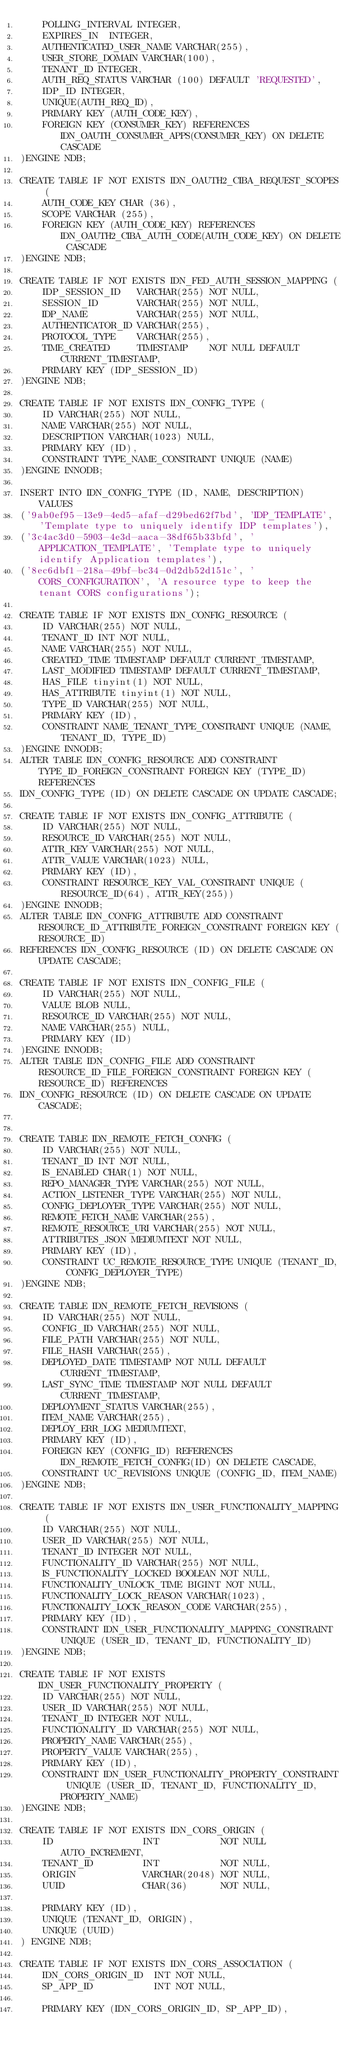Convert code to text. <code><loc_0><loc_0><loc_500><loc_500><_SQL_>    POLLING_INTERVAL INTEGER,
    EXPIRES_IN  INTEGER,
    AUTHENTICATED_USER_NAME VARCHAR(255),
    USER_STORE_DOMAIN VARCHAR(100),
    TENANT_ID INTEGER,
    AUTH_REQ_STATUS VARCHAR (100) DEFAULT 'REQUESTED',
    IDP_ID INTEGER,
    UNIQUE(AUTH_REQ_ID),
    PRIMARY KEY (AUTH_CODE_KEY),
    FOREIGN KEY (CONSUMER_KEY) REFERENCES IDN_OAUTH_CONSUMER_APPS(CONSUMER_KEY) ON DELETE CASCADE
)ENGINE NDB;

CREATE TABLE IF NOT EXISTS IDN_OAUTH2_CIBA_REQUEST_SCOPES (
    AUTH_CODE_KEY CHAR (36),
    SCOPE VARCHAR (255),
    FOREIGN KEY (AUTH_CODE_KEY) REFERENCES IDN_OAUTH2_CIBA_AUTH_CODE(AUTH_CODE_KEY) ON DELETE CASCADE
)ENGINE NDB;

CREATE TABLE IF NOT EXISTS IDN_FED_AUTH_SESSION_MAPPING (
	IDP_SESSION_ID   VARCHAR(255) NOT NULL,
	SESSION_ID       VARCHAR(255) NOT NULL,
	IDP_NAME         VARCHAR(255) NOT NULL,
	AUTHENTICATOR_ID VARCHAR(255),
	PROTOCOL_TYPE    VARCHAR(255),
	TIME_CREATED     TIMESTAMP    NOT NULL DEFAULT CURRENT_TIMESTAMP,
	PRIMARY KEY (IDP_SESSION_ID)
)ENGINE NDB;

CREATE TABLE IF NOT EXISTS IDN_CONFIG_TYPE (
    ID VARCHAR(255) NOT NULL,
    NAME VARCHAR(255) NOT NULL,
    DESCRIPTION VARCHAR(1023) NULL,
    PRIMARY KEY (ID),
    CONSTRAINT TYPE_NAME_CONSTRAINT UNIQUE (NAME)
)ENGINE INNODB;

INSERT INTO IDN_CONFIG_TYPE (ID, NAME, DESCRIPTION) VALUES
('9ab0ef95-13e9-4ed5-afaf-d29bed62f7bd', 'IDP_TEMPLATE', 'Template type to uniquely identify IDP templates'),
('3c4ac3d0-5903-4e3d-aaca-38df65b33bfd', 'APPLICATION_TEMPLATE', 'Template type to uniquely identify Application templates'),
('8ec6dbf1-218a-49bf-bc34-0d2db52d151c', 'CORS_CONFIGURATION', 'A resource type to keep the tenant CORS configurations');

CREATE TABLE IF NOT EXISTS IDN_CONFIG_RESOURCE (
    ID VARCHAR(255) NOT NULL,
    TENANT_ID INT NOT NULL,
    NAME VARCHAR(255) NOT NULL,
    CREATED_TIME TIMESTAMP DEFAULT CURRENT_TIMESTAMP,
    LAST_MODIFIED TIMESTAMP DEFAULT CURRENT_TIMESTAMP,
    HAS_FILE tinyint(1) NOT NULL,
    HAS_ATTRIBUTE tinyint(1) NOT NULL,
    TYPE_ID VARCHAR(255) NOT NULL,
    PRIMARY KEY (ID),
    CONSTRAINT NAME_TENANT_TYPE_CONSTRAINT UNIQUE (NAME, TENANT_ID, TYPE_ID)
)ENGINE INNODB;
ALTER TABLE IDN_CONFIG_RESOURCE ADD CONSTRAINT TYPE_ID_FOREIGN_CONSTRAINT FOREIGN KEY (TYPE_ID) REFERENCES
IDN_CONFIG_TYPE (ID) ON DELETE CASCADE ON UPDATE CASCADE;

CREATE TABLE IF NOT EXISTS IDN_CONFIG_ATTRIBUTE (
    ID VARCHAR(255) NOT NULL,
    RESOURCE_ID VARCHAR(255) NOT NULL,
    ATTR_KEY VARCHAR(255) NOT NULL,
    ATTR_VALUE VARCHAR(1023) NULL,
    PRIMARY KEY (ID),
    CONSTRAINT RESOURCE_KEY_VAL_CONSTRAINT UNIQUE (RESOURCE_ID(64), ATTR_KEY(255))
)ENGINE INNODB;
ALTER TABLE IDN_CONFIG_ATTRIBUTE ADD CONSTRAINT RESOURCE_ID_ATTRIBUTE_FOREIGN_CONSTRAINT FOREIGN KEY (RESOURCE_ID)
REFERENCES IDN_CONFIG_RESOURCE (ID) ON DELETE CASCADE ON UPDATE CASCADE;

CREATE TABLE IF NOT EXISTS IDN_CONFIG_FILE (
    ID VARCHAR(255) NOT NULL,
    VALUE BLOB NULL,
    RESOURCE_ID VARCHAR(255) NOT NULL,
    NAME VARCHAR(255) NULL,
    PRIMARY KEY (ID)
)ENGINE INNODB;
ALTER TABLE IDN_CONFIG_FILE ADD CONSTRAINT RESOURCE_ID_FILE_FOREIGN_CONSTRAINT FOREIGN KEY (RESOURCE_ID) REFERENCES
IDN_CONFIG_RESOURCE (ID) ON DELETE CASCADE ON UPDATE CASCADE;


CREATE TABLE IDN_REMOTE_FETCH_CONFIG (
	ID VARCHAR(255) NOT NULL,
	TENANT_ID INT NOT NULL,
	IS_ENABLED CHAR(1) NOT NULL,
	REPO_MANAGER_TYPE VARCHAR(255) NOT NULL,
	ACTION_LISTENER_TYPE VARCHAR(255) NOT NULL,
	CONFIG_DEPLOYER_TYPE VARCHAR(255) NOT NULL,
	REMOTE_FETCH_NAME VARCHAR(255),
	REMOTE_RESOURCE_URI VARCHAR(255) NOT NULL,
	ATTRIBUTES_JSON MEDIUMTEXT NOT NULL,
	PRIMARY KEY (ID),
	CONSTRAINT UC_REMOTE_RESOURCE_TYPE UNIQUE (TENANT_ID, CONFIG_DEPLOYER_TYPE)
)ENGINE NDB;

CREATE TABLE IDN_REMOTE_FETCH_REVISIONS (
	ID VARCHAR(255) NOT NULL,
	CONFIG_ID VARCHAR(255) NOT NULL,
	FILE_PATH VARCHAR(255) NOT NULL,
	FILE_HASH VARCHAR(255),
	DEPLOYED_DATE TIMESTAMP NOT NULL DEFAULT CURRENT_TIMESTAMP,
	LAST_SYNC_TIME TIMESTAMP NOT NULL DEFAULT CURRENT_TIMESTAMP,
	DEPLOYMENT_STATUS VARCHAR(255),
	ITEM_NAME VARCHAR(255),
	DEPLOY_ERR_LOG MEDIUMTEXT,
	PRIMARY KEY (ID),
	FOREIGN KEY (CONFIG_ID) REFERENCES IDN_REMOTE_FETCH_CONFIG(ID) ON DELETE CASCADE,
	CONSTRAINT UC_REVISIONS UNIQUE (CONFIG_ID, ITEM_NAME)
)ENGINE NDB;

CREATE TABLE IF NOT EXISTS IDN_USER_FUNCTIONALITY_MAPPING (
	ID VARCHAR(255) NOT NULL,
	USER_ID VARCHAR(255) NOT NULL,
	TENANT_ID INTEGER NOT NULL,
	FUNCTIONALITY_ID VARCHAR(255) NOT NULL,
	IS_FUNCTIONALITY_LOCKED BOOLEAN NOT NULL,
	FUNCTIONALITY_UNLOCK_TIME BIGINT NOT NULL,
	FUNCTIONALITY_LOCK_REASON VARCHAR(1023),
	FUNCTIONALITY_LOCK_REASON_CODE VARCHAR(255),
	PRIMARY KEY (ID),
	CONSTRAINT IDN_USER_FUNCTIONALITY_MAPPING_CONSTRAINT UNIQUE (USER_ID, TENANT_ID, FUNCTIONALITY_ID)
)ENGINE NDB;

CREATE TABLE IF NOT EXISTS IDN_USER_FUNCTIONALITY_PROPERTY (
	ID VARCHAR(255) NOT NULL,
	USER_ID VARCHAR(255) NOT NULL,
	TENANT_ID INTEGER NOT NULL,
	FUNCTIONALITY_ID VARCHAR(255) NOT NULL,
	PROPERTY_NAME VARCHAR(255),
	PROPERTY_VALUE VARCHAR(255),
	PRIMARY KEY (ID),
	CONSTRAINT IDN_USER_FUNCTIONALITY_PROPERTY_CONSTRAINT UNIQUE (USER_ID, TENANT_ID, FUNCTIONALITY_ID, PROPERTY_NAME)
)ENGINE NDB;

CREATE TABLE IF NOT EXISTS IDN_CORS_ORIGIN (
    ID                INT           NOT NULL AUTO_INCREMENT,
    TENANT_ID         INT           NOT NULL,
    ORIGIN            VARCHAR(2048) NOT NULL,
    UUID              CHAR(36)      NOT NULL,

    PRIMARY KEY (ID),
    UNIQUE (TENANT_ID, ORIGIN),
    UNIQUE (UUID)
) ENGINE NDB;

CREATE TABLE IF NOT EXISTS IDN_CORS_ASSOCIATION (
    IDN_CORS_ORIGIN_ID  INT NOT NULL,
    SP_APP_ID           INT NOT NULL,

    PRIMARY KEY (IDN_CORS_ORIGIN_ID, SP_APP_ID),</code> 